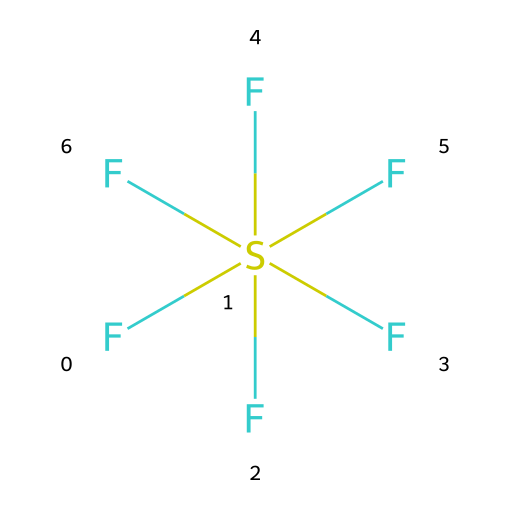How many fluorine atoms are present in sulfur hexafluoride? The SMILES representation shows six 'F' atoms and one sulfur (S) atom attached to the sulfur. The number of 'F' letters indicates there are six fluorine atoms.
Answer: six What is the central atom in the chemical structure of sulfur hexafluoride? The SMILES indicates that the sulfur atom (S) is the central atom because it is the only atom connected to multiple fluorine atoms, showcasing its role in the structure.
Answer: sulfur How many bonds does sulfur form with fluorine in this compound? The structure shows one sulfur atom bonded to six fluorine atoms. Each fluorine is single bonded to the central sulfur atom. Thus, there are six bonds in total.
Answer: six What hybridization does the sulfur atom exhibit in sulfur hexafluoride? The structure illustrates that sulfur is surrounded by six fluorine atoms, which implies sp3d2 hybridization since it has six bonding pairs.
Answer: sp3d2 What property makes sulfur hexafluoride a common insulating gas? The high electronegativity of fluorine and the molecular structure lead to a stable, non-polar assembly making it an excellent insulator.
Answer: stability Is sulfur hexafluoride a hypervalent compound? The presence of six bonds to a single central sulfur atom indicates that sulfur exceeds the octet rule, classifying it as a hypervalent compound.
Answer: yes Why is sulfur hexafluoride used in electrical equipment? Its structure leads to non-polar characteristics, making it effective at preventing electrical discharge in high-voltage applications.
Answer: non-polar 